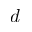<formula> <loc_0><loc_0><loc_500><loc_500>d</formula> 